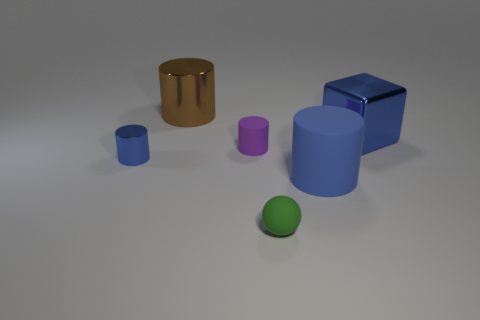Subtract all large blue cylinders. How many cylinders are left? 3 Subtract all brown cylinders. How many cylinders are left? 3 Subtract 1 cylinders. How many cylinders are left? 3 Subtract all red spheres. How many blue cylinders are left? 2 Add 3 big green matte objects. How many objects exist? 9 Subtract all cylinders. How many objects are left? 2 Subtract all cyan blocks. Subtract all gray balls. How many blocks are left? 1 Subtract all big red matte objects. Subtract all large brown cylinders. How many objects are left? 5 Add 1 tiny balls. How many tiny balls are left? 2 Add 1 big rubber blocks. How many big rubber blocks exist? 1 